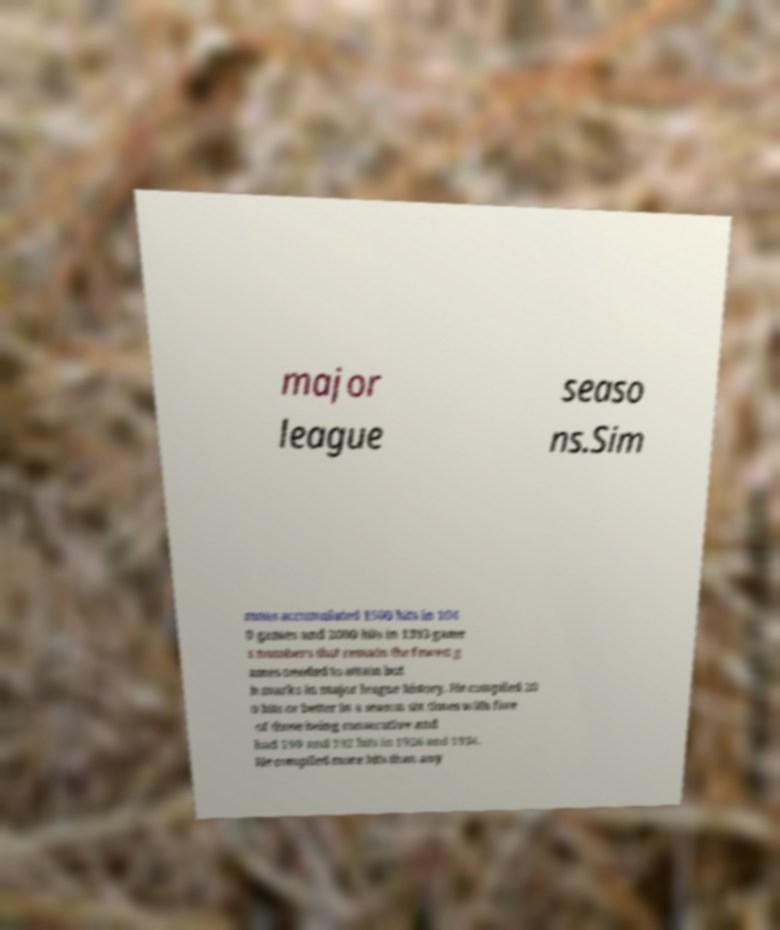Please read and relay the text visible in this image. What does it say? major league seaso ns.Sim mons accumulated 1500 hits in 104 0 games and 2000 hits in 1393 game s numbers that remain the fewest g ames needed to attain bot h marks in major league history. He compiled 20 0 hits or better in a season six times with five of those being consecutive and had 199 and 192 hits in 1926 and 1934. He compiled more hits than any 